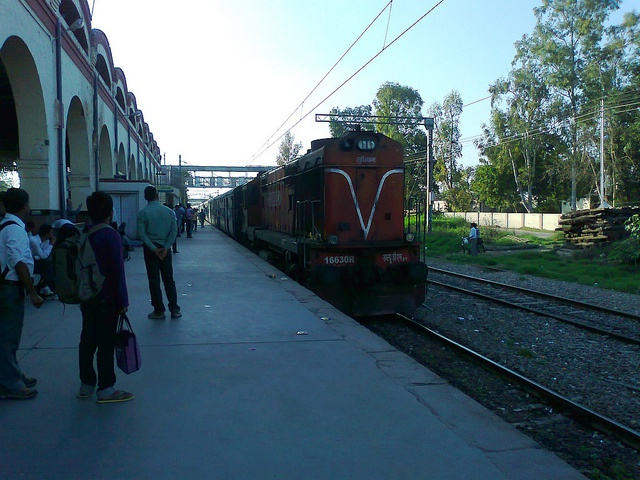Describe the objects in this image and their specific colors. I can see train in gray, black, and purple tones, people in gray, black, blue, navy, and darkgreen tones, people in gray, black, blue, navy, and teal tones, people in gray, black, darkblue, blue, and teal tones, and backpack in gray, black, navy, blue, and teal tones in this image. 